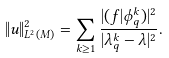Convert formula to latex. <formula><loc_0><loc_0><loc_500><loc_500>\| u \| _ { L ^ { 2 } ( M ) } ^ { 2 } = \sum _ { k \geq 1 } \frac { | ( f | \phi _ { q } ^ { k } ) | ^ { 2 } } { | \lambda _ { q } ^ { k } - \lambda | ^ { 2 } } .</formula> 